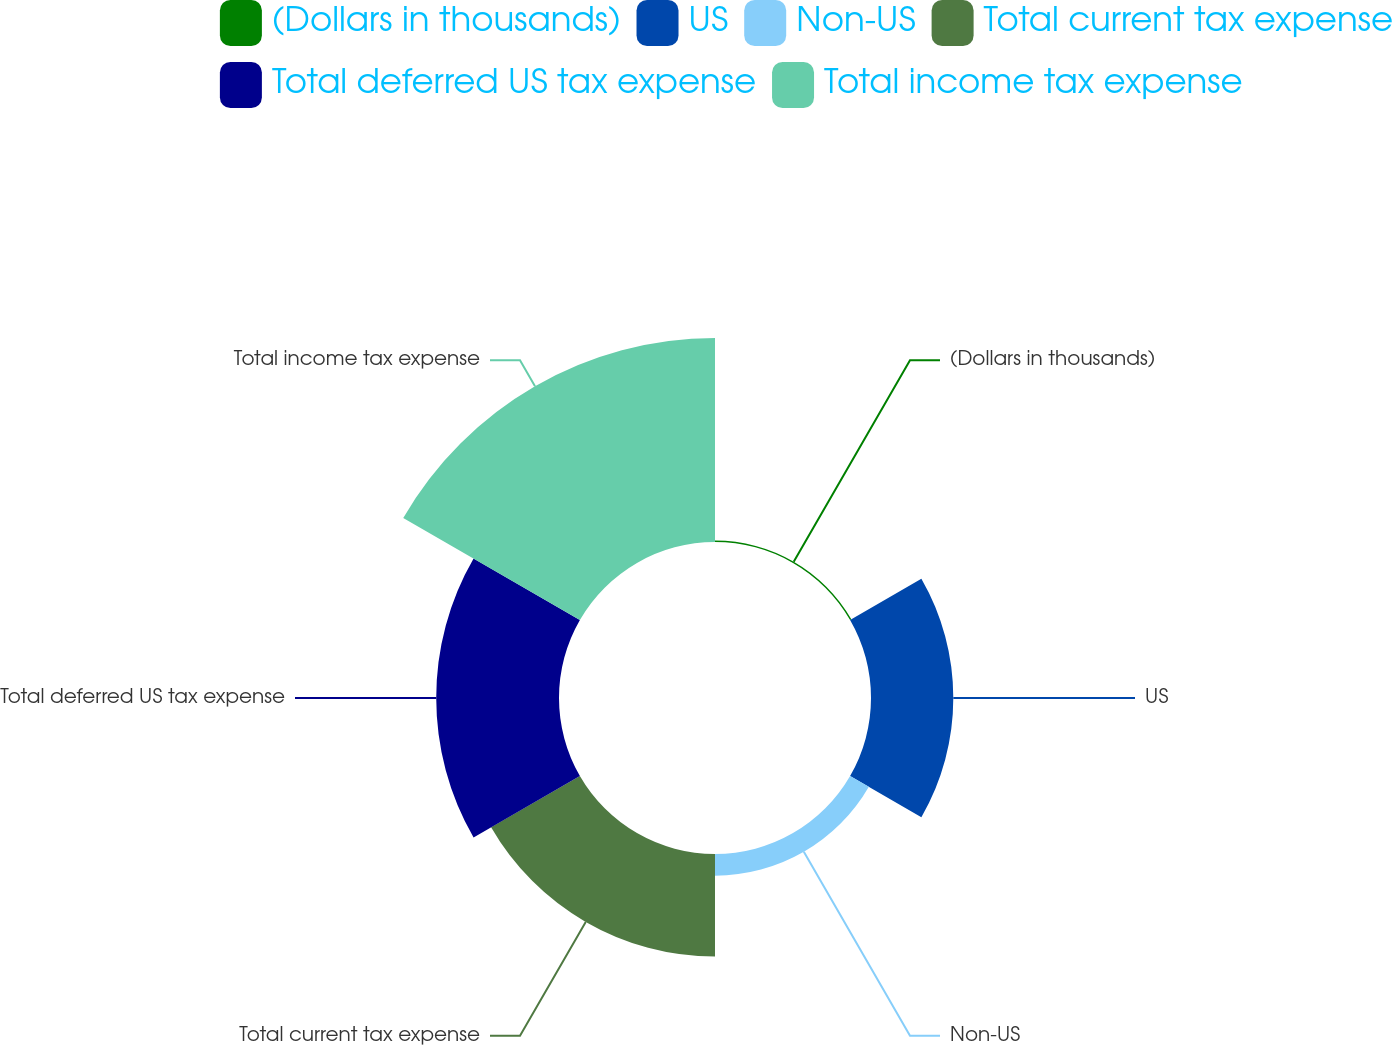<chart> <loc_0><loc_0><loc_500><loc_500><pie_chart><fcel>(Dollars in thousands)<fcel>US<fcel>Non-US<fcel>Total current tax expense<fcel>Total deferred US tax expense<fcel>Total income tax expense<nl><fcel>0.27%<fcel>15.39%<fcel>4.05%<fcel>19.18%<fcel>22.96%<fcel>38.15%<nl></chart> 